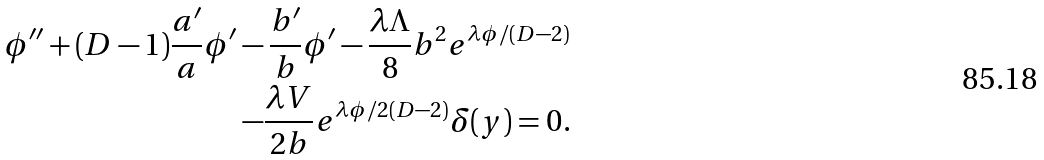Convert formula to latex. <formula><loc_0><loc_0><loc_500><loc_500>\phi ^ { \prime \prime } + ( D - 1 ) \frac { a ^ { \prime } } { a } \phi ^ { \prime } - \frac { b ^ { \prime } } { b } \phi ^ { \prime } - \frac { \lambda \Lambda } { 8 } b ^ { 2 } e ^ { \lambda \phi / ( D - 2 ) } \\ - \frac { \lambda V } { 2 b } e ^ { \lambda \phi / 2 ( D - 2 ) } \delta ( y ) = 0 .</formula> 